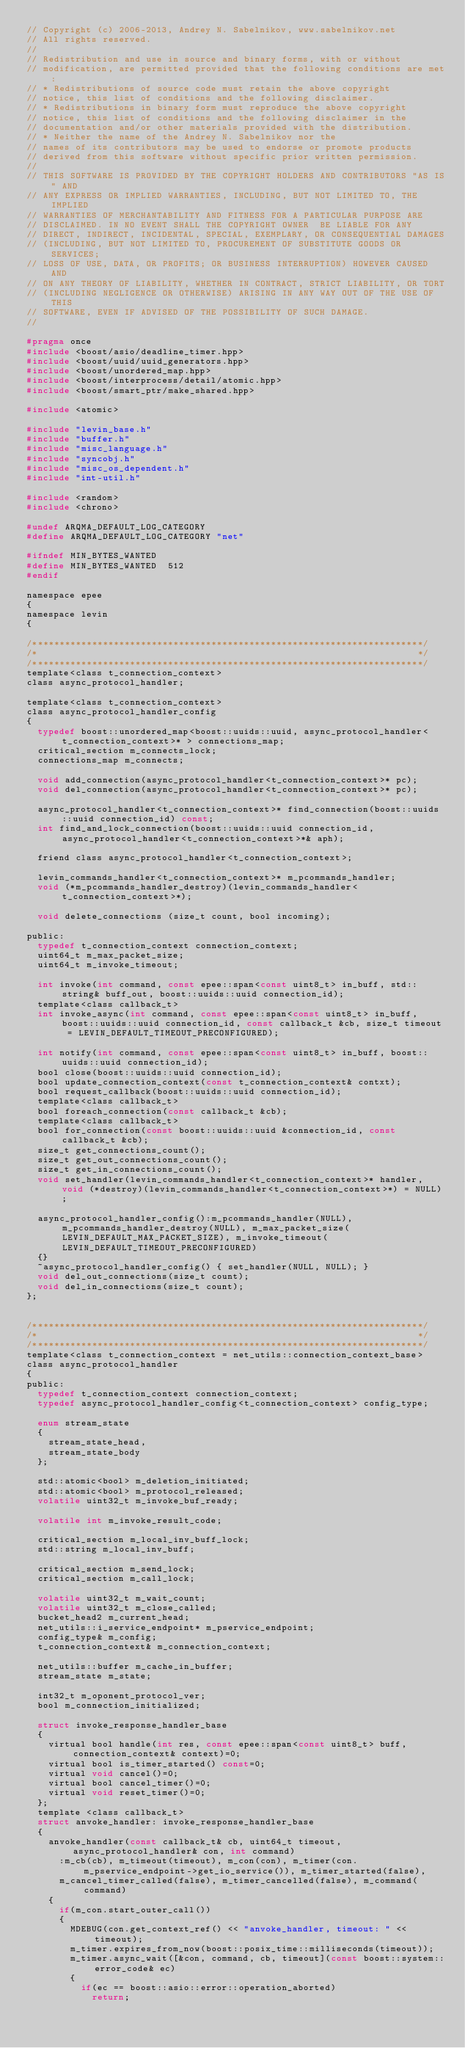Convert code to text. <code><loc_0><loc_0><loc_500><loc_500><_C_>// Copyright (c) 2006-2013, Andrey N. Sabelnikov, www.sabelnikov.net
// All rights reserved.
//
// Redistribution and use in source and binary forms, with or without
// modification, are permitted provided that the following conditions are met:
// * Redistributions of source code must retain the above copyright
// notice, this list of conditions and the following disclaimer.
// * Redistributions in binary form must reproduce the above copyright
// notice, this list of conditions and the following disclaimer in the
// documentation and/or other materials provided with the distribution.
// * Neither the name of the Andrey N. Sabelnikov nor the
// names of its contributors may be used to endorse or promote products
// derived from this software without specific prior written permission.
//
// THIS SOFTWARE IS PROVIDED BY THE COPYRIGHT HOLDERS AND CONTRIBUTORS "AS IS" AND
// ANY EXPRESS OR IMPLIED WARRANTIES, INCLUDING, BUT NOT LIMITED TO, THE IMPLIED
// WARRANTIES OF MERCHANTABILITY AND FITNESS FOR A PARTICULAR PURPOSE ARE
// DISCLAIMED. IN NO EVENT SHALL THE COPYRIGHT OWNER  BE LIABLE FOR ANY
// DIRECT, INDIRECT, INCIDENTAL, SPECIAL, EXEMPLARY, OR CONSEQUENTIAL DAMAGES
// (INCLUDING, BUT NOT LIMITED TO, PROCUREMENT OF SUBSTITUTE GOODS OR SERVICES;
// LOSS OF USE, DATA, OR PROFITS; OR BUSINESS INTERRUPTION) HOWEVER CAUSED AND
// ON ANY THEORY OF LIABILITY, WHETHER IN CONTRACT, STRICT LIABILITY, OR TORT
// (INCLUDING NEGLIGENCE OR OTHERWISE) ARISING IN ANY WAY OUT OF THE USE OF THIS
// SOFTWARE, EVEN IF ADVISED OF THE POSSIBILITY OF SUCH DAMAGE.
//

#pragma once
#include <boost/asio/deadline_timer.hpp>
#include <boost/uuid/uuid_generators.hpp>
#include <boost/unordered_map.hpp>
#include <boost/interprocess/detail/atomic.hpp>
#include <boost/smart_ptr/make_shared.hpp>

#include <atomic>

#include "levin_base.h"
#include "buffer.h"
#include "misc_language.h"
#include "syncobj.h"
#include "misc_os_dependent.h"
#include "int-util.h"

#include <random>
#include <chrono>

#undef ARQMA_DEFAULT_LOG_CATEGORY
#define ARQMA_DEFAULT_LOG_CATEGORY "net"

#ifndef MIN_BYTES_WANTED
#define MIN_BYTES_WANTED	512
#endif

namespace epee
{
namespace levin
{

/************************************************************************/
/*                                                                      */
/************************************************************************/
template<class t_connection_context>
class async_protocol_handler;

template<class t_connection_context>
class async_protocol_handler_config
{
  typedef boost::unordered_map<boost::uuids::uuid, async_protocol_handler<t_connection_context>* > connections_map;
  critical_section m_connects_lock;
  connections_map m_connects;

  void add_connection(async_protocol_handler<t_connection_context>* pc);
  void del_connection(async_protocol_handler<t_connection_context>* pc);

  async_protocol_handler<t_connection_context>* find_connection(boost::uuids::uuid connection_id) const;
  int find_and_lock_connection(boost::uuids::uuid connection_id, async_protocol_handler<t_connection_context>*& aph);

  friend class async_protocol_handler<t_connection_context>;

  levin_commands_handler<t_connection_context>* m_pcommands_handler;
  void (*m_pcommands_handler_destroy)(levin_commands_handler<t_connection_context>*);

  void delete_connections (size_t count, bool incoming);

public:
  typedef t_connection_context connection_context;
  uint64_t m_max_packet_size;
  uint64_t m_invoke_timeout;

  int invoke(int command, const epee::span<const uint8_t> in_buff, std::string& buff_out, boost::uuids::uuid connection_id);
  template<class callback_t>
  int invoke_async(int command, const epee::span<const uint8_t> in_buff, boost::uuids::uuid connection_id, const callback_t &cb, size_t timeout = LEVIN_DEFAULT_TIMEOUT_PRECONFIGURED);

  int notify(int command, const epee::span<const uint8_t> in_buff, boost::uuids::uuid connection_id);
  bool close(boost::uuids::uuid connection_id);
  bool update_connection_context(const t_connection_context& contxt);
  bool request_callback(boost::uuids::uuid connection_id);
  template<class callback_t>
  bool foreach_connection(const callback_t &cb);
  template<class callback_t>
  bool for_connection(const boost::uuids::uuid &connection_id, const callback_t &cb);
  size_t get_connections_count();
  size_t get_out_connections_count();
  size_t get_in_connections_count();
  void set_handler(levin_commands_handler<t_connection_context>* handler, void (*destroy)(levin_commands_handler<t_connection_context>*) = NULL);

  async_protocol_handler_config():m_pcommands_handler(NULL), m_pcommands_handler_destroy(NULL), m_max_packet_size(LEVIN_DEFAULT_MAX_PACKET_SIZE), m_invoke_timeout(LEVIN_DEFAULT_TIMEOUT_PRECONFIGURED)
  {}
  ~async_protocol_handler_config() { set_handler(NULL, NULL); }
  void del_out_connections(size_t count);
  void del_in_connections(size_t count);
};


/************************************************************************/
/*                                                                      */
/************************************************************************/
template<class t_connection_context = net_utils::connection_context_base>
class async_protocol_handler
{
public:
  typedef t_connection_context connection_context;
  typedef async_protocol_handler_config<t_connection_context> config_type;

  enum stream_state
  {
    stream_state_head,
    stream_state_body
  };

  std::atomic<bool> m_deletion_initiated;
  std::atomic<bool> m_protocol_released;
  volatile uint32_t m_invoke_buf_ready;

  volatile int m_invoke_result_code;

  critical_section m_local_inv_buff_lock;
  std::string m_local_inv_buff;

  critical_section m_send_lock;
  critical_section m_call_lock;

  volatile uint32_t m_wait_count;
  volatile uint32_t m_close_called;
  bucket_head2 m_current_head;
  net_utils::i_service_endpoint* m_pservice_endpoint;
  config_type& m_config;
  t_connection_context& m_connection_context;

  net_utils::buffer m_cache_in_buffer;
  stream_state m_state;

  int32_t m_oponent_protocol_ver;
  bool m_connection_initialized;

  struct invoke_response_handler_base
  {
    virtual bool handle(int res, const epee::span<const uint8_t> buff, connection_context& context)=0;
    virtual bool is_timer_started() const=0;
    virtual void cancel()=0;
    virtual bool cancel_timer()=0;
    virtual void reset_timer()=0;
  };
  template <class callback_t>
  struct anvoke_handler: invoke_response_handler_base
  {
    anvoke_handler(const callback_t& cb, uint64_t timeout, async_protocol_handler& con, int command)
      :m_cb(cb), m_timeout(timeout), m_con(con), m_timer(con.m_pservice_endpoint->get_io_service()), m_timer_started(false),
      m_cancel_timer_called(false), m_timer_cancelled(false), m_command(command)
    {
      if(m_con.start_outer_call())
      {
        MDEBUG(con.get_context_ref() << "anvoke_handler, timeout: " << timeout);
        m_timer.expires_from_now(boost::posix_time::milliseconds(timeout));
        m_timer.async_wait([&con, command, cb, timeout](const boost::system::error_code& ec)
        {
          if(ec == boost::asio::error::operation_aborted)
            return;</code> 